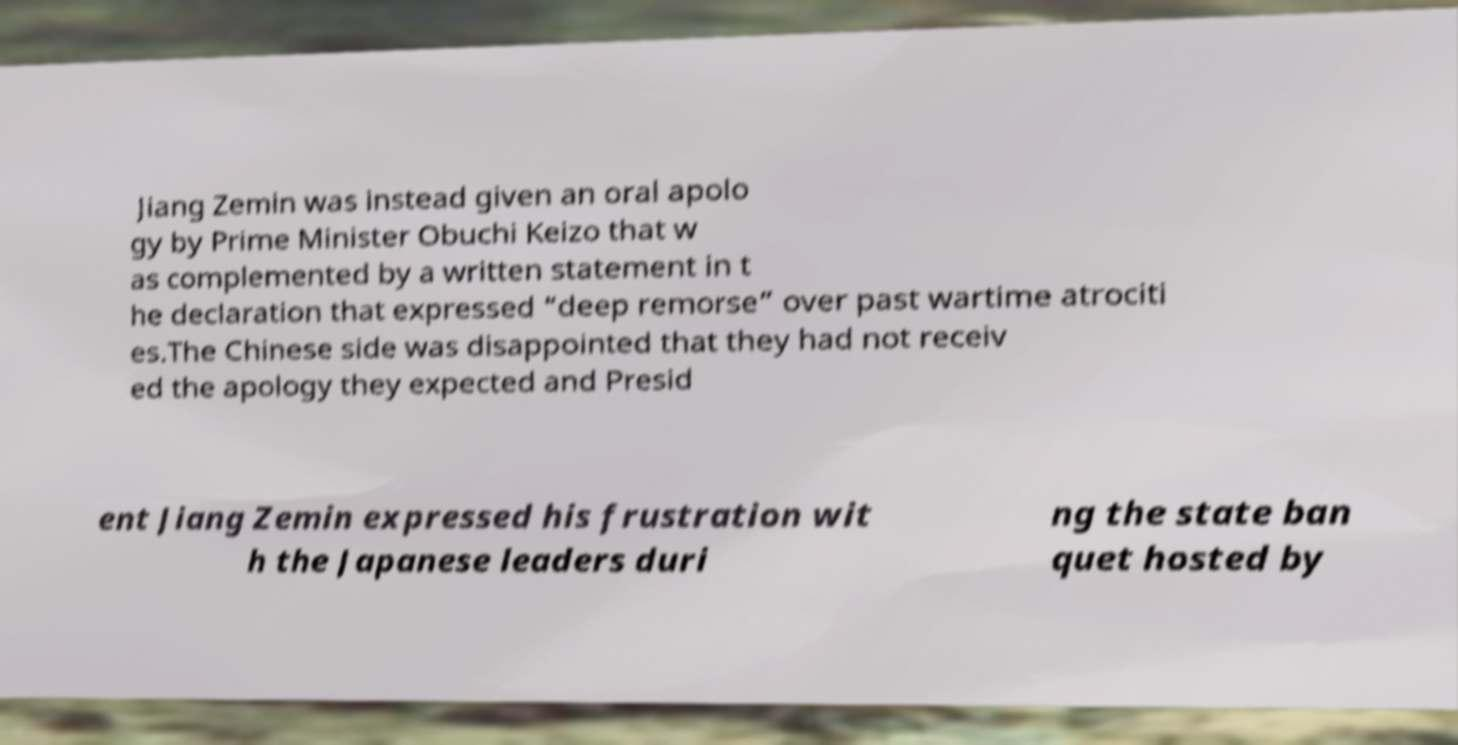What messages or text are displayed in this image? I need them in a readable, typed format. Jiang Zemin was instead given an oral apolo gy by Prime Minister Obuchi Keizo that w as complemented by a written statement in t he declaration that expressed “deep remorse” over past wartime atrociti es.The Chinese side was disappointed that they had not receiv ed the apology they expected and Presid ent Jiang Zemin expressed his frustration wit h the Japanese leaders duri ng the state ban quet hosted by 